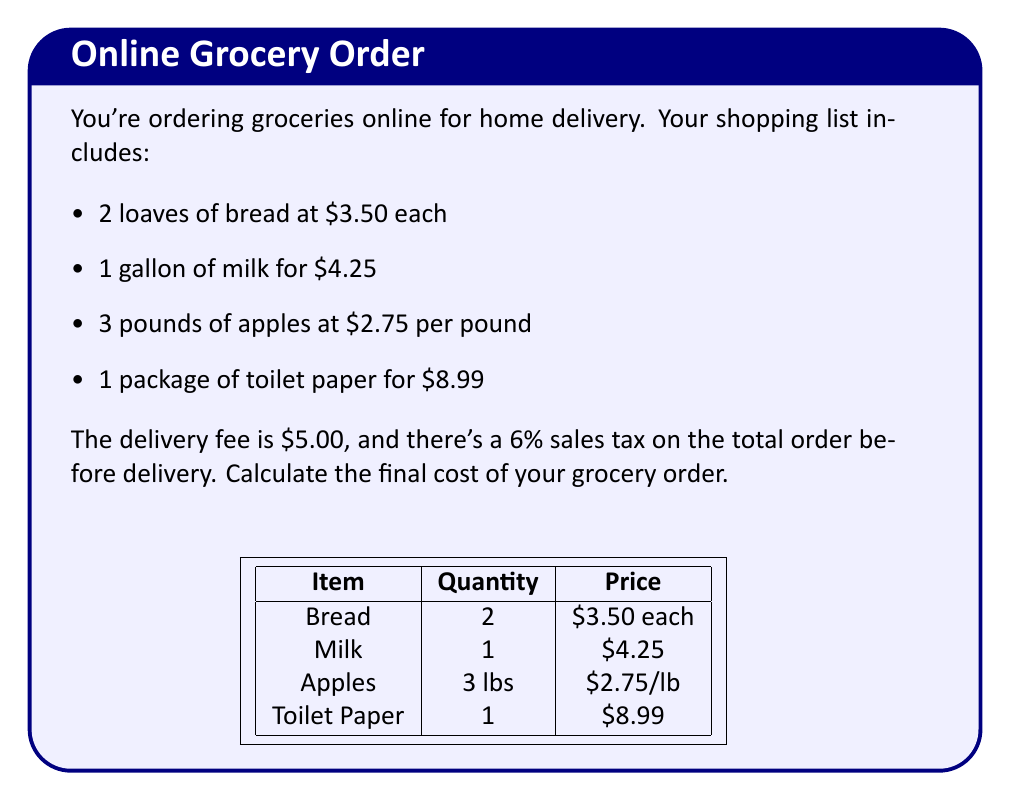Could you help me with this problem? Let's break this down step-by-step:

1. Calculate the cost of bread:
   $2 \times \$3.50 = \$7.00$

2. Cost of milk:
   $\$4.25$ (already given)

3. Calculate the cost of apples:
   $3 \times \$2.75 = \$8.25$

4. Cost of toilet paper:
   $\$8.99$ (already given)

5. Sum up the cost of all items:
   $\$7.00 + \$4.25 + \$8.25 + \$8.99 = \$28.49$

6. Calculate the sales tax:
   $6\% \text{ of } \$28.49 = 0.06 \times \$28.49 = \$1.71$

7. Add the sales tax to the subtotal:
   $\$28.49 + \$1.71 = \$30.20$

8. Add the delivery fee:
   $\$30.20 + \$5.00 = \$35.20$

Therefore, the final cost of your grocery order is $\$35.20$.
Answer: $\$35.20$ 